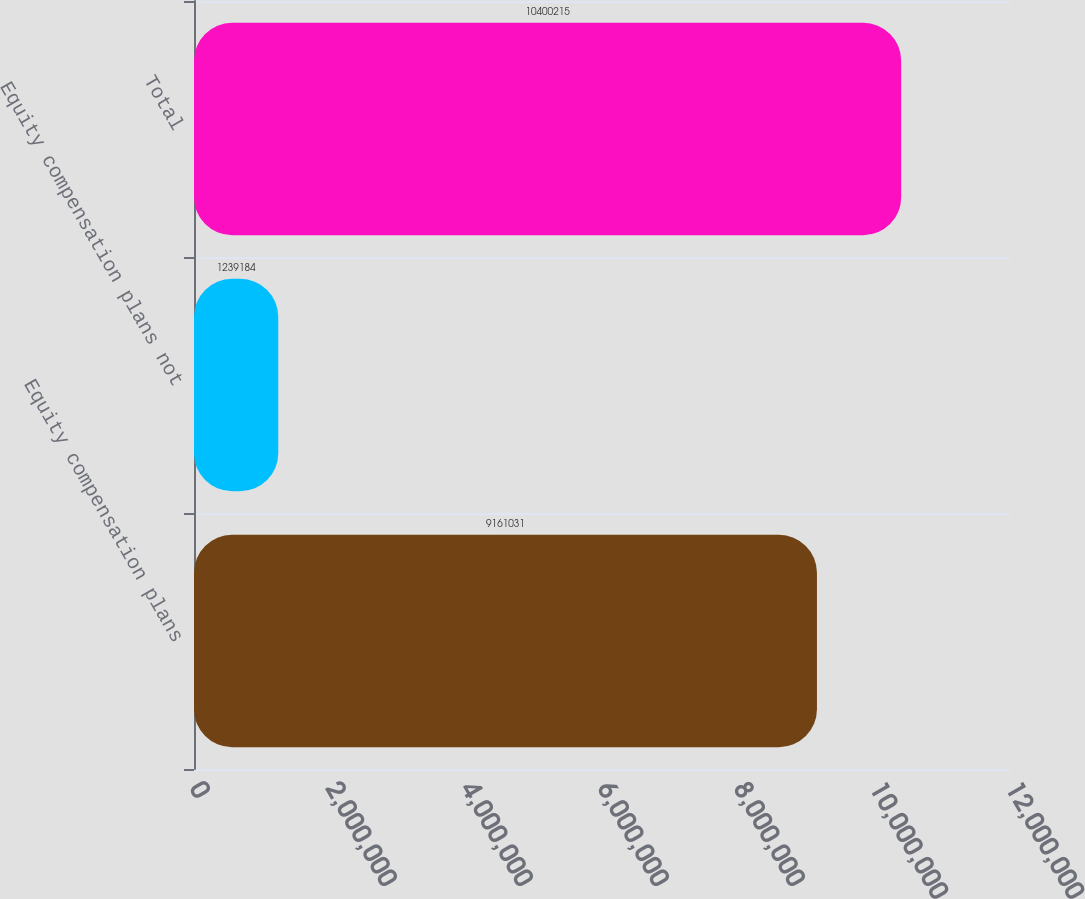Convert chart. <chart><loc_0><loc_0><loc_500><loc_500><bar_chart><fcel>Equity compensation plans<fcel>Equity compensation plans not<fcel>Total<nl><fcel>9.16103e+06<fcel>1.23918e+06<fcel>1.04002e+07<nl></chart> 